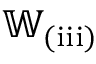<formula> <loc_0><loc_0><loc_500><loc_500>\mathbb { W } _ { ( i i i ) }</formula> 